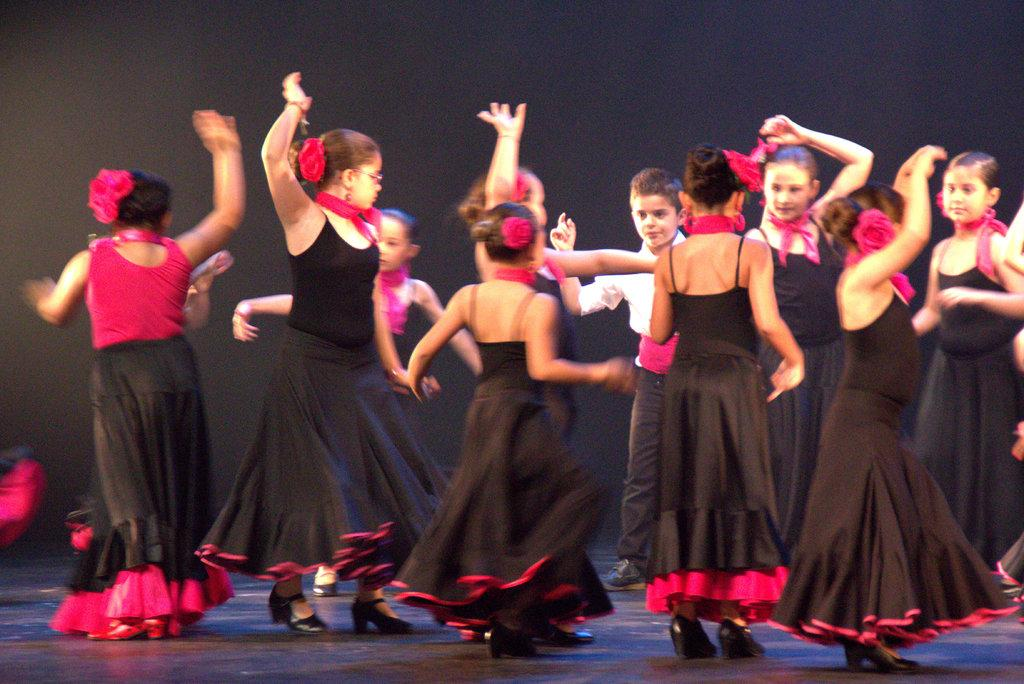What is the main subject of the image? The main subject of the image is a group of girls. What are the girls wearing in the image? The girls are wearing black dresses in the image. What are the girls doing in the image? The girls are performing a dance on a stage in the image. Can you describe the boy visible in the image? There is a boy visible between the girls in the image. What can be seen in the background of the image? The background of the image has a dark view. What type of haircut does the mom have in the image? There is no mom present in the image, so it is not possible to answer that question. 